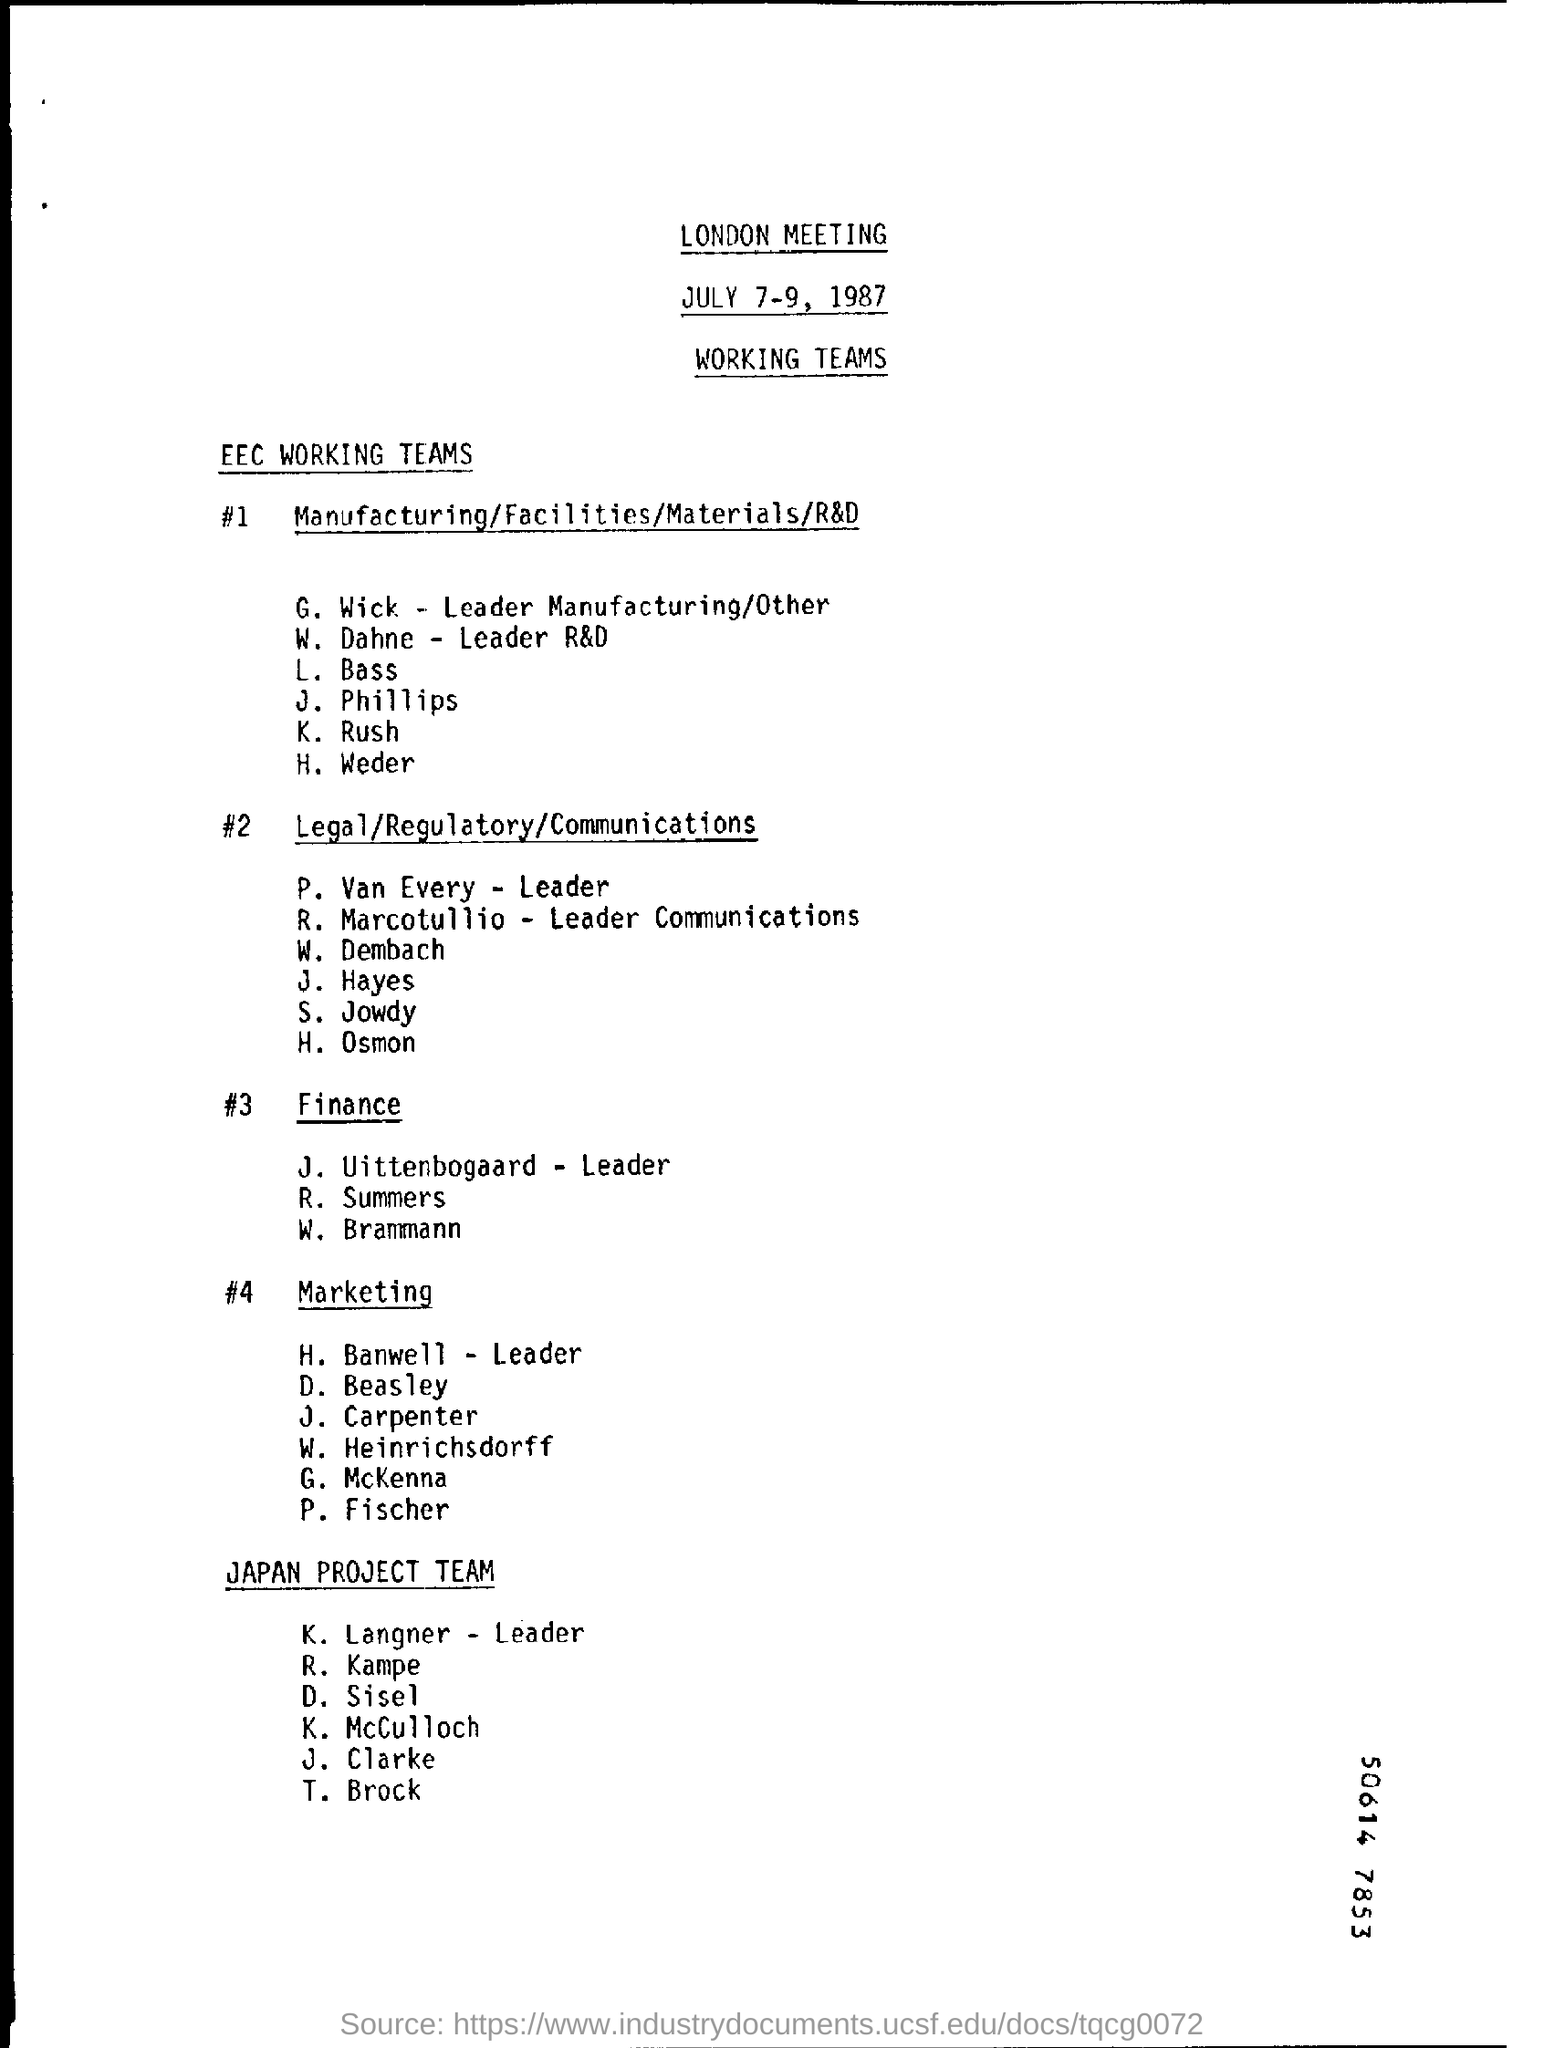Mention a couple of crucial points in this snapshot. The date at the top of this document is July 7-9, 1987. 